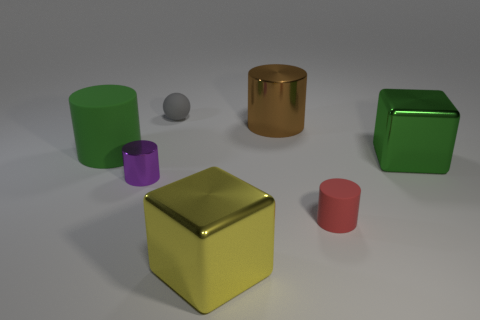There is a cube in front of the green thing that is right of the large brown thing to the right of the purple cylinder; what size is it?
Offer a very short reply. Large. Is the number of matte cylinders greater than the number of tiny objects?
Your answer should be very brief. No. Do the big cylinder that is on the left side of the brown cylinder and the big object that is to the right of the big brown metallic object have the same color?
Provide a succinct answer. Yes. Are the cube that is behind the red object and the tiny cylinder on the right side of the big yellow metal cube made of the same material?
Your answer should be very brief. No. How many purple shiny cylinders are the same size as the brown thing?
Keep it short and to the point. 0. Is the number of big metal blocks less than the number of big brown metallic cylinders?
Provide a short and direct response. No. There is a large thing that is behind the large green object that is left of the tiny purple cylinder; what shape is it?
Provide a short and direct response. Cylinder. There is a metal object that is the same size as the rubber sphere; what is its shape?
Your response must be concise. Cylinder. Is there a large yellow metallic object of the same shape as the big brown thing?
Your response must be concise. No. What is the brown cylinder made of?
Your answer should be very brief. Metal. 